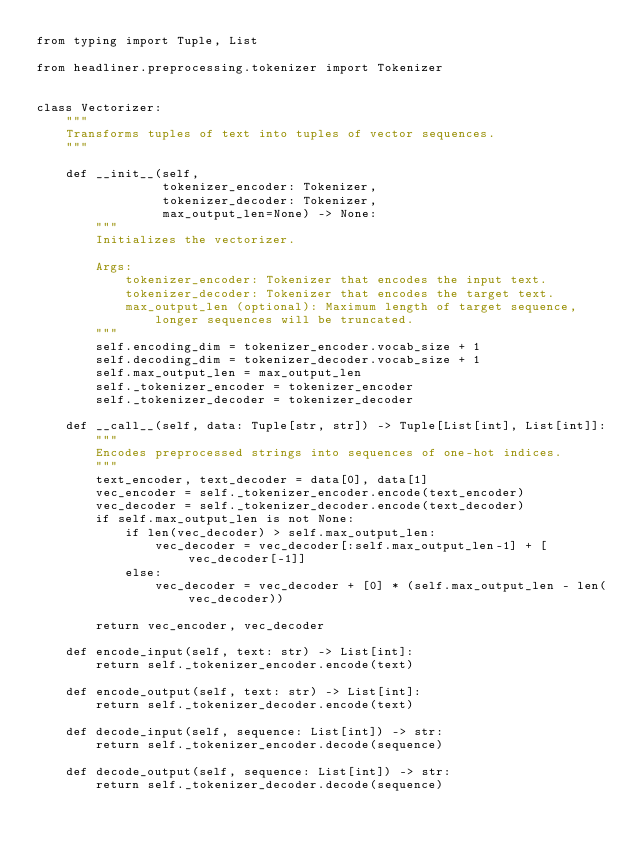<code> <loc_0><loc_0><loc_500><loc_500><_Python_>from typing import Tuple, List

from headliner.preprocessing.tokenizer import Tokenizer


class Vectorizer:
    """
    Transforms tuples of text into tuples of vector sequences.
    """

    def __init__(self,
                 tokenizer_encoder: Tokenizer,
                 tokenizer_decoder: Tokenizer,
                 max_output_len=None) -> None:
        """
        Initializes the vectorizer.

        Args:
            tokenizer_encoder: Tokenizer that encodes the input text.
            tokenizer_decoder: Tokenizer that encodes the target text.
            max_output_len (optional): Maximum length of target sequence,
                longer sequences will be truncated.
        """
        self.encoding_dim = tokenizer_encoder.vocab_size + 1
        self.decoding_dim = tokenizer_decoder.vocab_size + 1
        self.max_output_len = max_output_len
        self._tokenizer_encoder = tokenizer_encoder
        self._tokenizer_decoder = tokenizer_decoder

    def __call__(self, data: Tuple[str, str]) -> Tuple[List[int], List[int]]:
        """
        Encodes preprocessed strings into sequences of one-hot indices.
        """
        text_encoder, text_decoder = data[0], data[1]
        vec_encoder = self._tokenizer_encoder.encode(text_encoder)
        vec_decoder = self._tokenizer_decoder.encode(text_decoder)
        if self.max_output_len is not None:
            if len(vec_decoder) > self.max_output_len:
                vec_decoder = vec_decoder[:self.max_output_len-1] + [vec_decoder[-1]]
            else:
                vec_decoder = vec_decoder + [0] * (self.max_output_len - len(vec_decoder))

        return vec_encoder, vec_decoder

    def encode_input(self, text: str) -> List[int]:
        return self._tokenizer_encoder.encode(text)

    def encode_output(self, text: str) -> List[int]:
        return self._tokenizer_decoder.encode(text)

    def decode_input(self, sequence: List[int]) -> str:
        return self._tokenizer_encoder.decode(sequence)

    def decode_output(self, sequence: List[int]) -> str:
        return self._tokenizer_decoder.decode(sequence)
</code> 